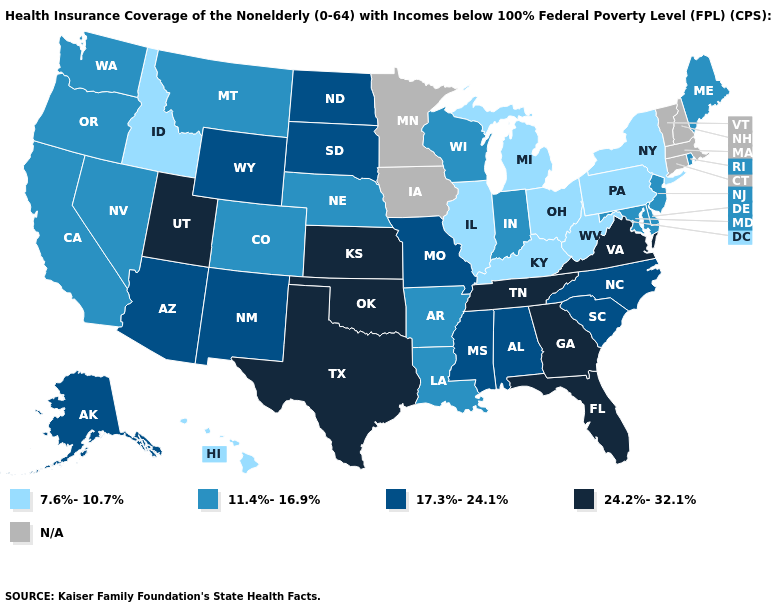Name the states that have a value in the range 7.6%-10.7%?
Concise answer only. Hawaii, Idaho, Illinois, Kentucky, Michigan, New York, Ohio, Pennsylvania, West Virginia. What is the highest value in the West ?
Give a very brief answer. 24.2%-32.1%. Among the states that border Michigan , does Ohio have the highest value?
Short answer required. No. What is the lowest value in states that border New Mexico?
Answer briefly. 11.4%-16.9%. Name the states that have a value in the range N/A?
Write a very short answer. Connecticut, Iowa, Massachusetts, Minnesota, New Hampshire, Vermont. Is the legend a continuous bar?
Concise answer only. No. How many symbols are there in the legend?
Give a very brief answer. 5. What is the lowest value in states that border Utah?
Keep it brief. 7.6%-10.7%. Name the states that have a value in the range 17.3%-24.1%?
Keep it brief. Alabama, Alaska, Arizona, Mississippi, Missouri, New Mexico, North Carolina, North Dakota, South Carolina, South Dakota, Wyoming. Name the states that have a value in the range 11.4%-16.9%?
Write a very short answer. Arkansas, California, Colorado, Delaware, Indiana, Louisiana, Maine, Maryland, Montana, Nebraska, Nevada, New Jersey, Oregon, Rhode Island, Washington, Wisconsin. Which states have the lowest value in the Northeast?
Short answer required. New York, Pennsylvania. What is the highest value in the West ?
Short answer required. 24.2%-32.1%. 